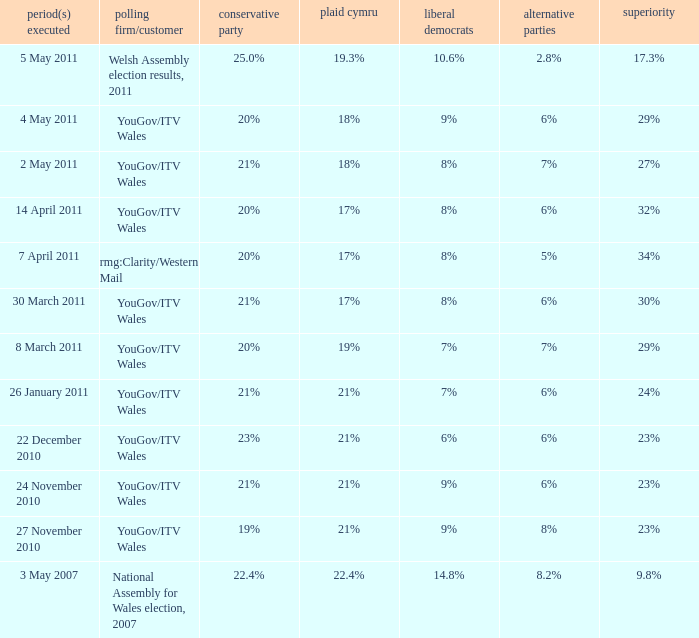I want the lead for others being 5% 34%. 